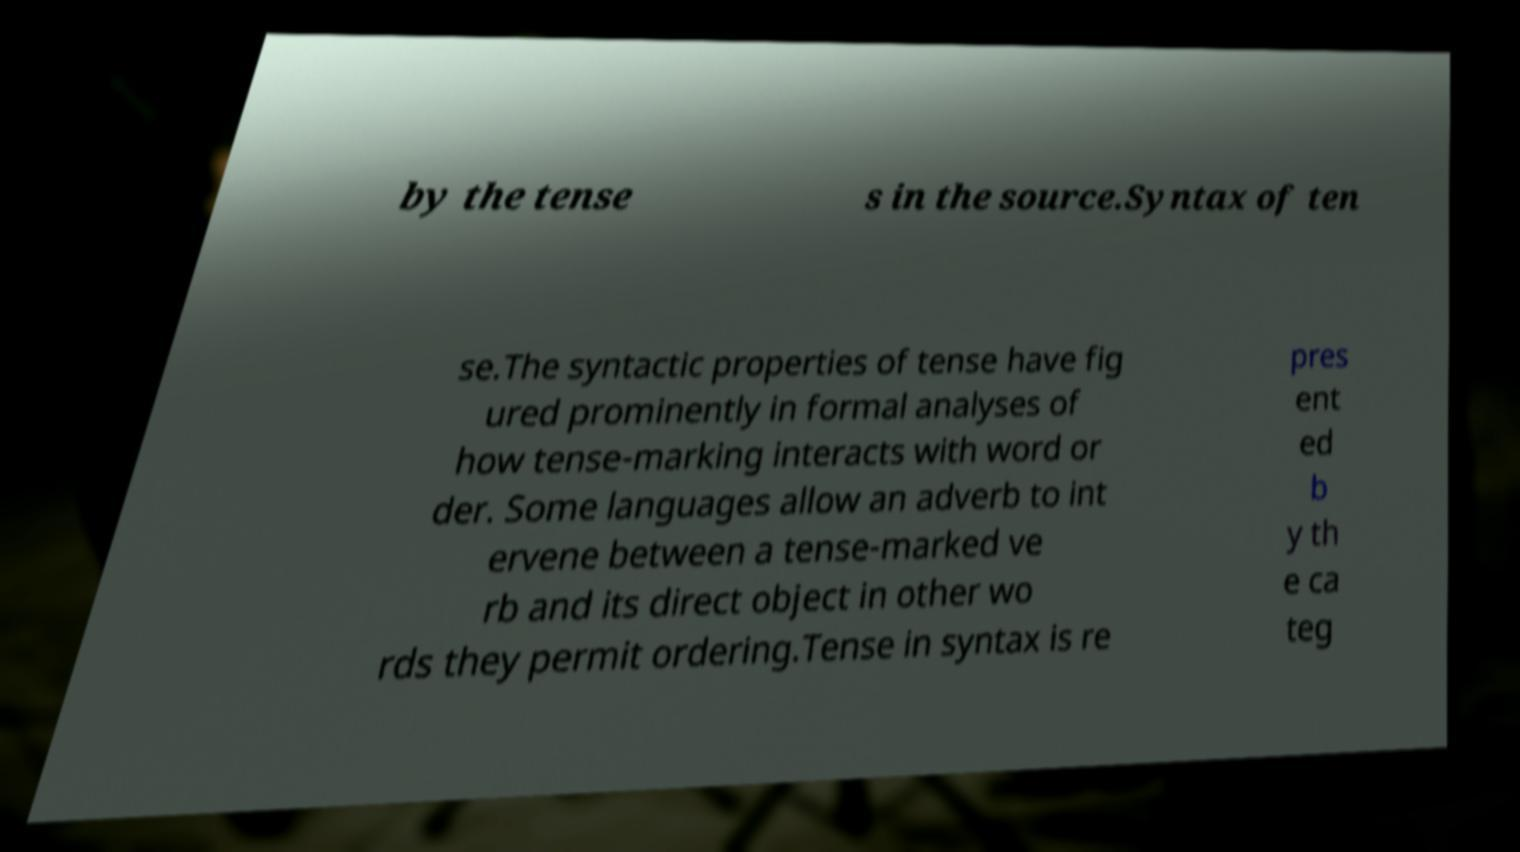Please identify and transcribe the text found in this image. by the tense s in the source.Syntax of ten se.The syntactic properties of tense have fig ured prominently in formal analyses of how tense-marking interacts with word or der. Some languages allow an adverb to int ervene between a tense-marked ve rb and its direct object in other wo rds they permit ordering.Tense in syntax is re pres ent ed b y th e ca teg 